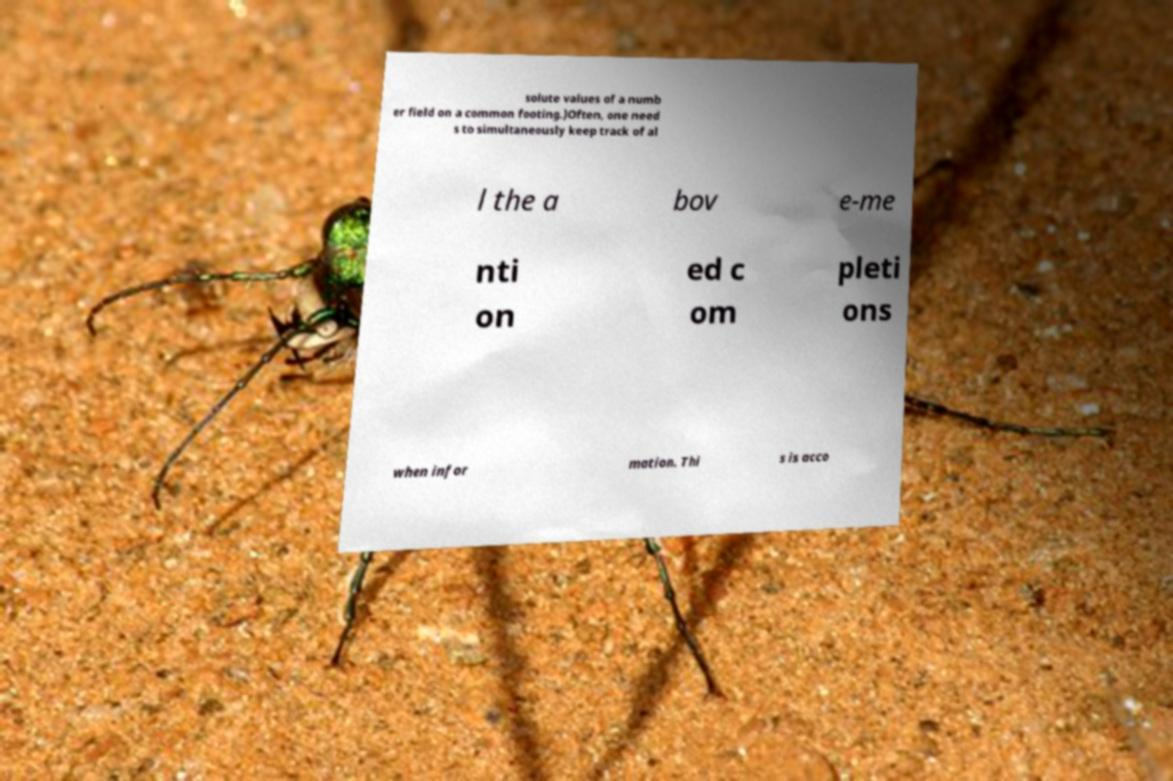Could you assist in decoding the text presented in this image and type it out clearly? solute values of a numb er field on a common footing.)Often, one need s to simultaneously keep track of al l the a bov e-me nti on ed c om pleti ons when infor mation. Thi s is acco 